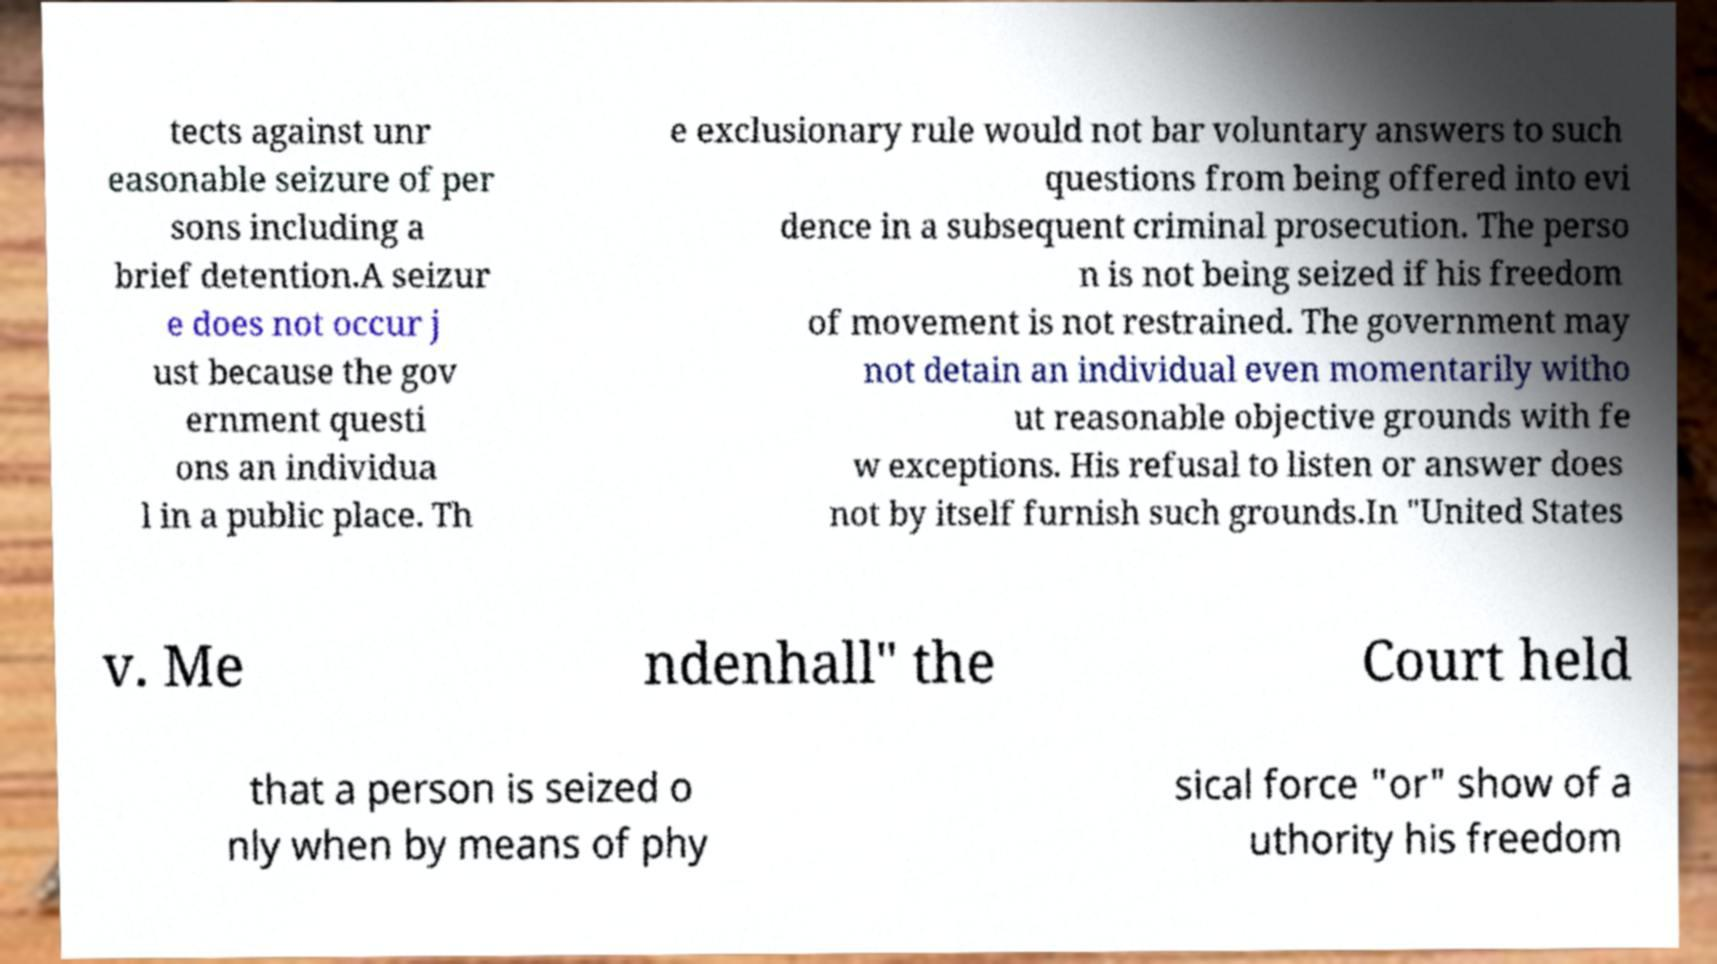Can you read and provide the text displayed in the image?This photo seems to have some interesting text. Can you extract and type it out for me? tects against unr easonable seizure of per sons including a brief detention.A seizur e does not occur j ust because the gov ernment questi ons an individua l in a public place. Th e exclusionary rule would not bar voluntary answers to such questions from being offered into evi dence in a subsequent criminal prosecution. The perso n is not being seized if his freedom of movement is not restrained. The government may not detain an individual even momentarily witho ut reasonable objective grounds with fe w exceptions. His refusal to listen or answer does not by itself furnish such grounds.In "United States v. Me ndenhall" the Court held that a person is seized o nly when by means of phy sical force "or" show of a uthority his freedom 